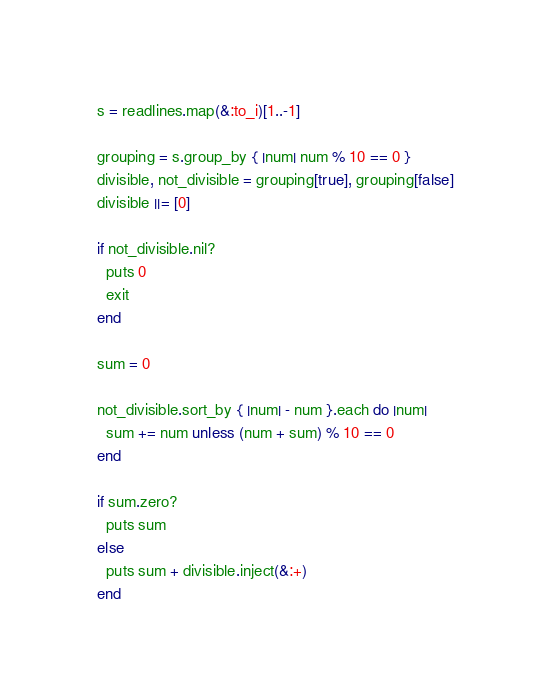<code> <loc_0><loc_0><loc_500><loc_500><_Ruby_>s = readlines.map(&:to_i)[1..-1]

grouping = s.group_by { |num| num % 10 == 0 }
divisible, not_divisible = grouping[true], grouping[false]
divisible ||= [0]

if not_divisible.nil?
  puts 0
  exit
end

sum = 0

not_divisible.sort_by { |num| - num }.each do |num|
  sum += num unless (num + sum) % 10 == 0
end

if sum.zero?
  puts sum
else
  puts sum + divisible.inject(&:+)
end
</code> 